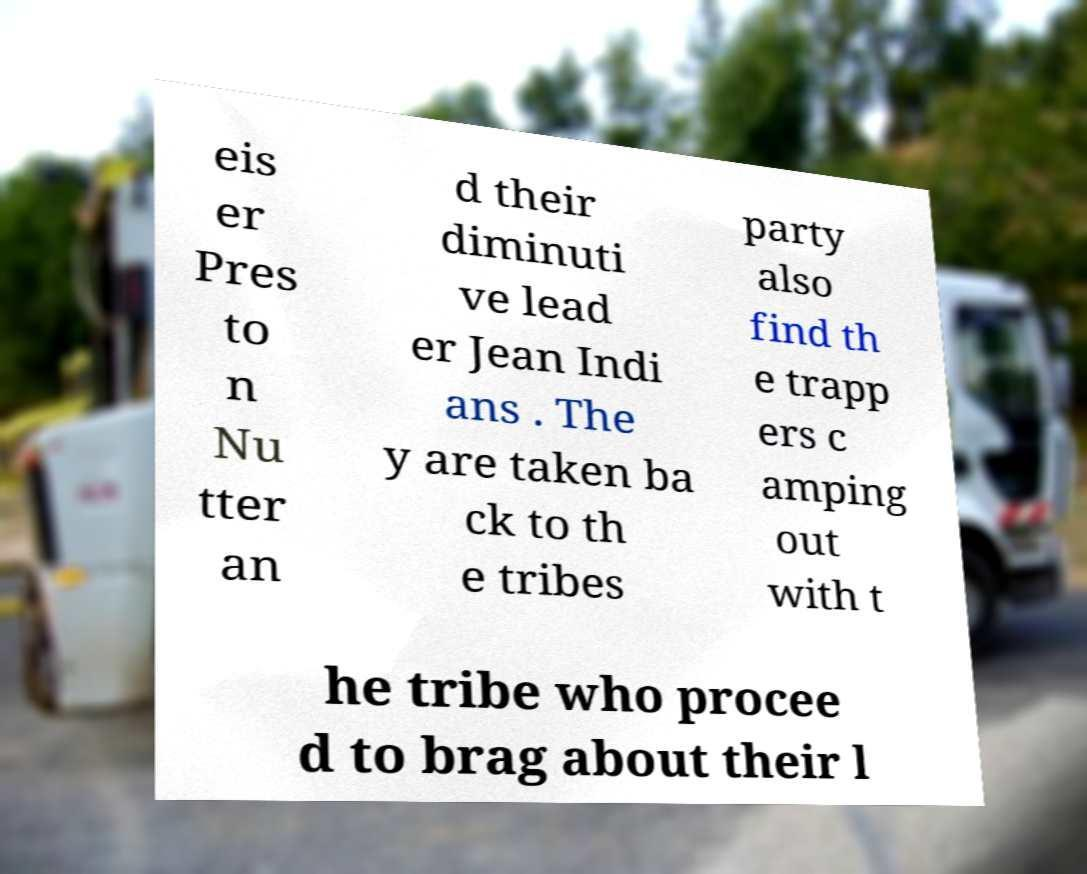For documentation purposes, I need the text within this image transcribed. Could you provide that? eis er Pres to n Nu tter an d their diminuti ve lead er Jean Indi ans . The y are taken ba ck to th e tribes party also find th e trapp ers c amping out with t he tribe who procee d to brag about their l 